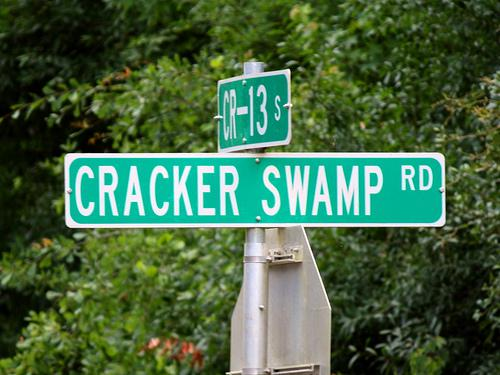Question: where was the photo taken?
Choices:
A. On a boat.
B. In a parking lot.
C. Near signs.
D. On a mountain.
Answer with the letter. Answer: C Question: what does the bottom sign say?
Choices:
A. No right turns.
B. "CRACKER SWAMP".
C. No parking.
D. Enter at own risk.
Answer with the letter. Answer: B Question: how many green signs are there?
Choices:
A. Three.
B. Four.
C. Two.
D. One.
Answer with the letter. Answer: C Question: what is green?
Choices:
A. Plants.
B. Trees.
C. Bushes.
D. Shrubs.
Answer with the letter. Answer: B Question: what is gray?
Choices:
A. Lamp Pole.
B. Parking Meter.
C. Street sign pole.
D. Back of a sign.
Answer with the letter. Answer: D 